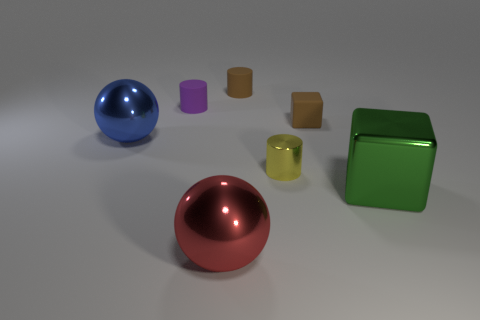Subtract all matte cylinders. How many cylinders are left? 1 Add 2 large metal spheres. How many objects exist? 9 Subtract all tiny red metallic things. Subtract all yellow shiny things. How many objects are left? 6 Add 5 large green objects. How many large green objects are left? 6 Add 5 large green matte balls. How many large green matte balls exist? 5 Subtract 0 green cylinders. How many objects are left? 7 Subtract all cylinders. How many objects are left? 4 